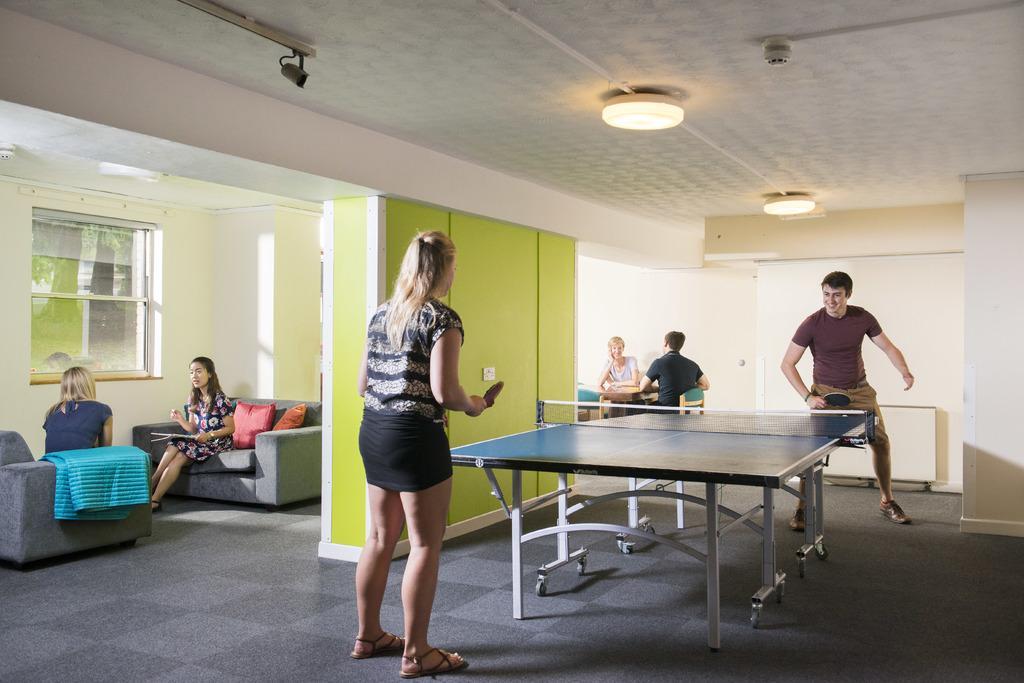Describe this image in one or two sentences. A woman and man playing table tennis and two women sat on sofa with cushions on it talking with each other beside a wall, and the wall has glass window on it. The ceiling has two lights and security camera mounted on it. And there another man and woman sitting at the backside of the room on a chair. 